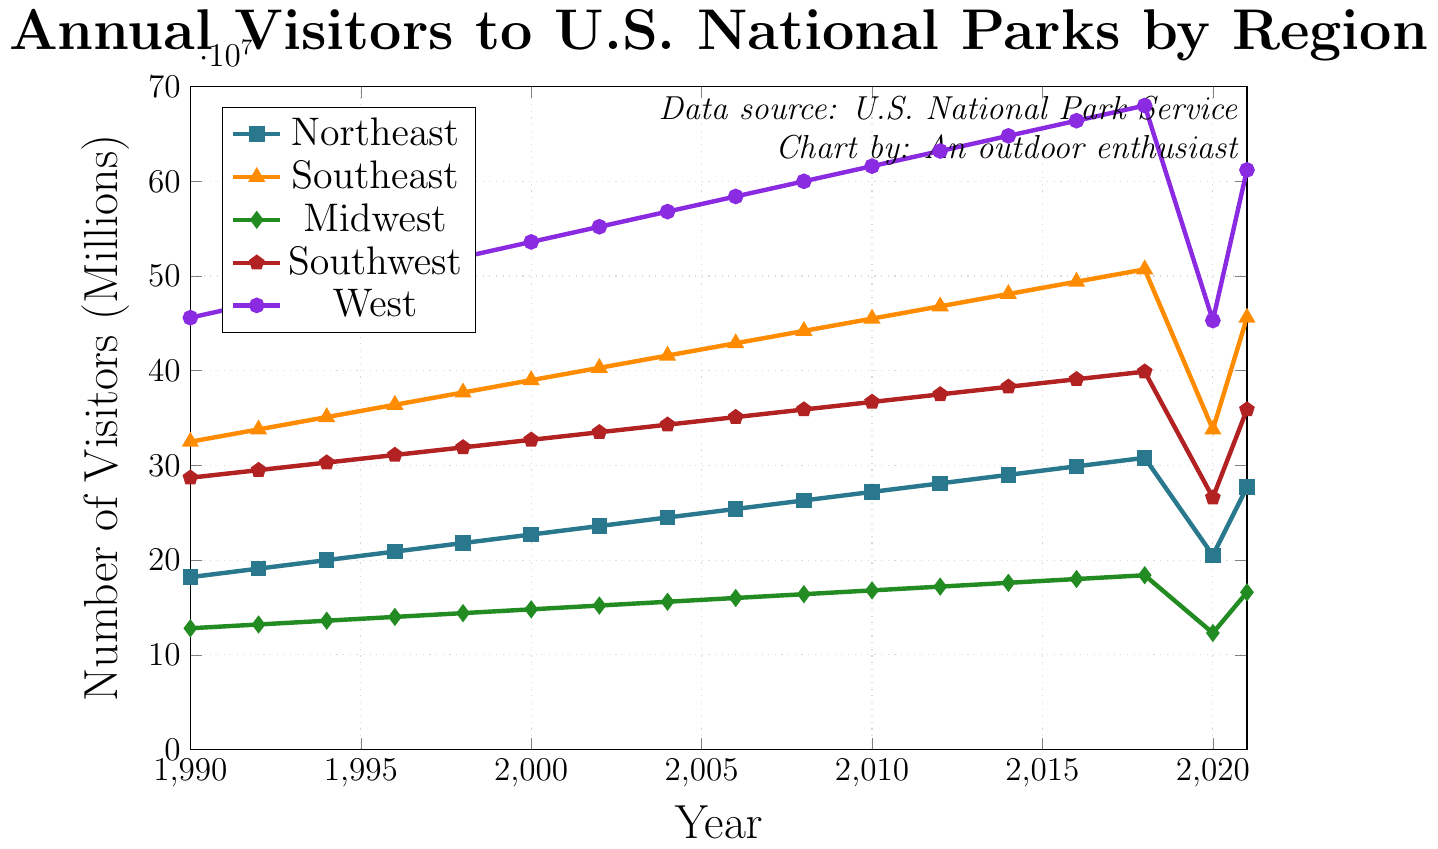What trend do you observe for the number of visitors to the Northeast region from 1990 to 2018? From the chart, the number of visitors to the Northeast region shows a consistent upward trend from 1990 to 2018. Starting at 18.2 million in 1990 and increasing to 30.8 million in 2018.
Answer: Rising trend Which region had the most significant drop in visitors from 2018 to 2020, and approximately how many visitors did it lose? The West region had the most significant drop in visitors from 2018 to 2020, going from approximately 68 million visitors in 2018 to 45.3 million visitors in 2020. The loss is 68 million - 45.3 million = 22.7 million visitors.
Answer: West, 22.7 million How did the number of visitors change in the Southeast region from 1990 to 2021? The number of visitors in the Southeast region increased from 32.5 million in 1990 to 50.7 million in 2018, dropped to 33.8 million in 2020, and then rose again to 45.6 million in 2021.
Answer: Increased, dropped, increased Which region had the highest number of visitors in 2014? According to the chart, the West region had the highest number of visitors in 2014 with approximately 64.8 million.
Answer: West Between which years did the Southwest region see the most consistent increase in visitors? The Southwest region saw the most consistent increase from 1990 to 2018, where the number of visitors increased steadily from 28.7 million in 1990 to 39.9 million in 2018.
Answer: 1990 to 2018 Compare the number of visitors to Midwest and Northeast regions in 2021. Which had more visitors and by how much? In 2021, the Midwest had 16.6 million visitors, while the Northeast had 27.7 million visitors. The Northeast had more visitors by 27.7 million - 16.6 million = 11.1 million visitors.
Answer: Northeast by 11.1 million What is the average number of visitors to the West region in the years 1990 and 2018? The number of visitors to the West in 1990 was 45.6 million and in 2018 it was 68 million. The average is (45.6 million + 68 million) / 2 = 56.8 million.
Answer: 56.8 million Which region had the smallest difference in visitors between 1990 and 2021? To find the smallest difference, we calculate for each region: 
Northeast: 27.7M - 18.2M = 9.5M 
Southeast: 45.6M - 32.5M = 13.1M 
Midwest: 16.6M - 12.8M = 3.8M 
Southwest: 35.9M - 28.7M = 7.2M 
West: 61.2M - 45.6M = 15.6M 
The Midwest region had the smallest difference of 3.8 million.
Answer: Midwest, 3.8 million Describe the trend observed in all regions in the year 2020. In 2020, all regions experienced a significant decline in the number of visitors, with the West, Southwest, Southeast, Midwest, and Northeast all showing dramatic drops compared to the previous years.
Answer: Decline What was the combined total number of visitors to all regions in 2016? Adding up the visitors in 2016: 
Northeast: 29.9M 
Southeast: 49.4M 
Midwest: 18M 
Southwest: 39.1M 
West: 66.4M 
Total = 29.9M + 49.4M + 18M + 39.1M + 66.4M = 202.8 million.
Answer: 202.8 million 